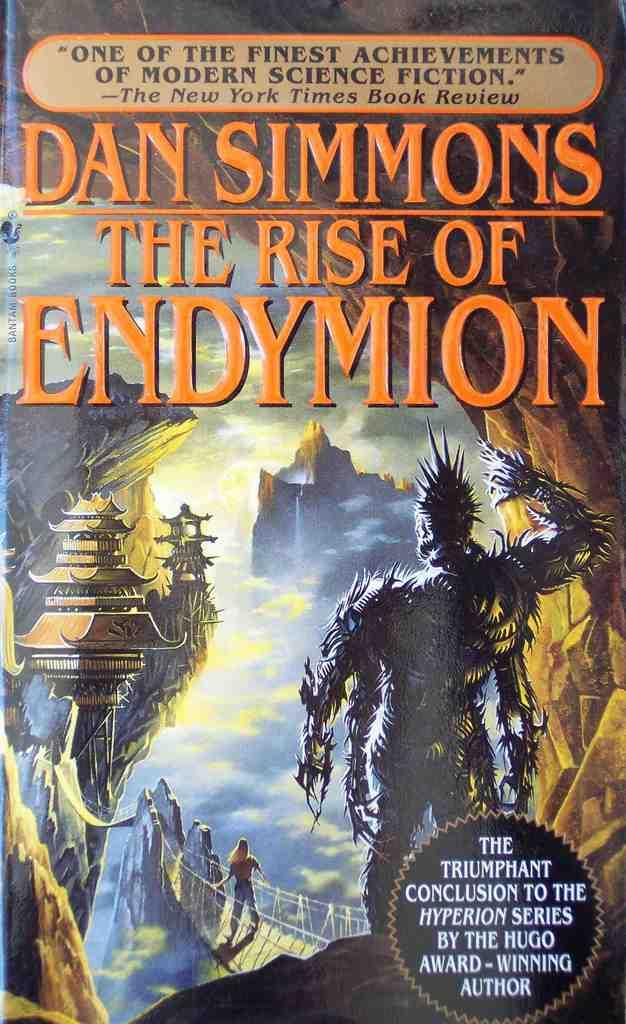Provide a one-sentence caption for the provided image. a cover of The Rise of Endymion by Dan Simmons. 